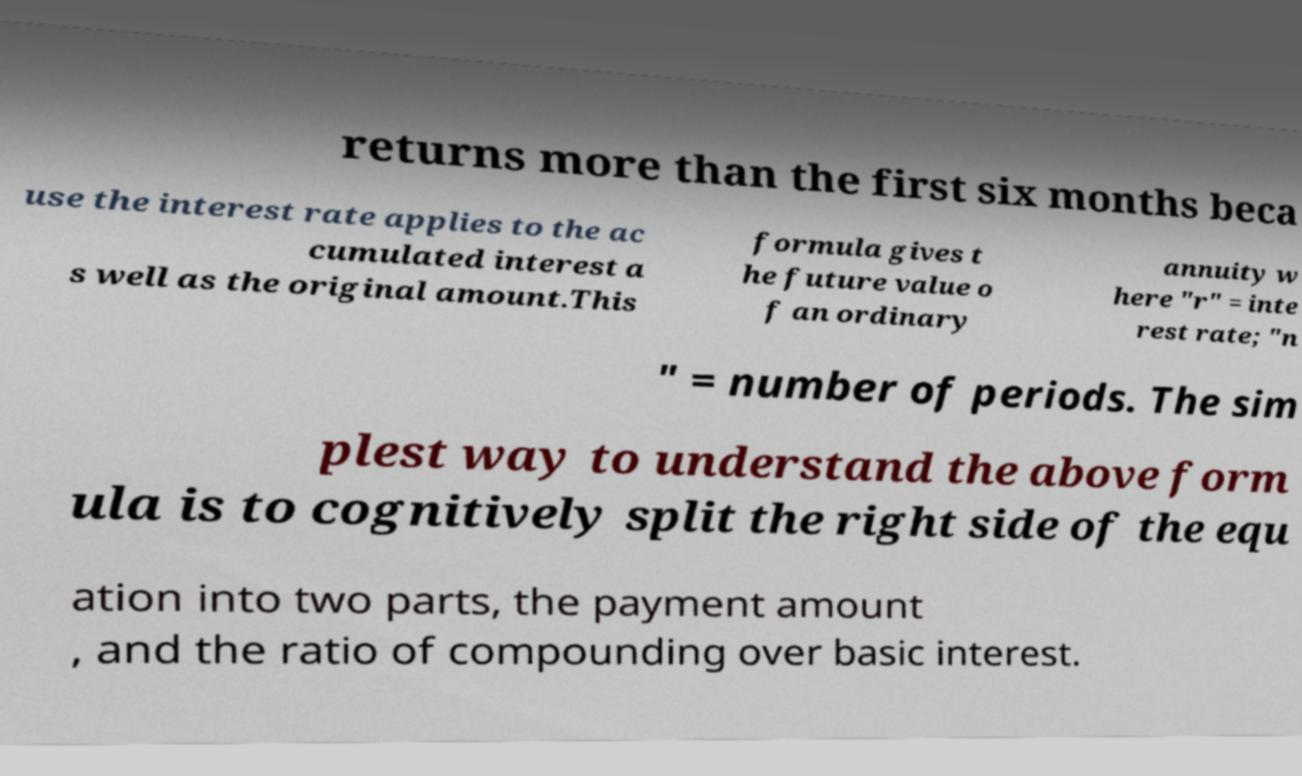Can you accurately transcribe the text from the provided image for me? returns more than the first six months beca use the interest rate applies to the ac cumulated interest a s well as the original amount.This formula gives t he future value o f an ordinary annuity w here "r" = inte rest rate; "n " = number of periods. The sim plest way to understand the above form ula is to cognitively split the right side of the equ ation into two parts, the payment amount , and the ratio of compounding over basic interest. 